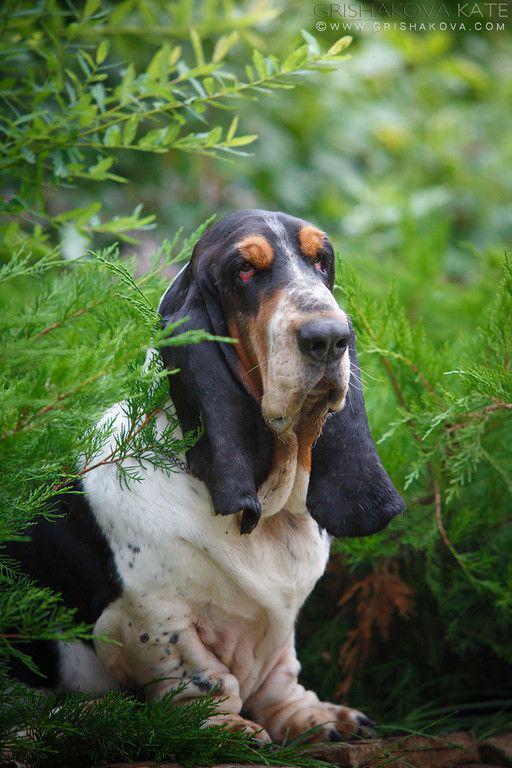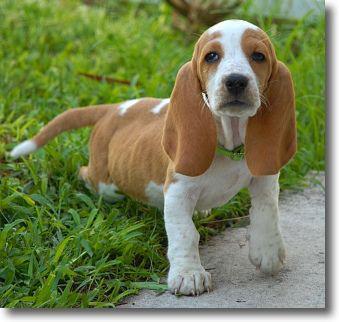The first image is the image on the left, the second image is the image on the right. Analyze the images presented: Is the assertion "One dog is howling." valid? Answer yes or no. No. The first image is the image on the left, the second image is the image on the right. Examine the images to the left and right. Is the description "The left image shows a howling basset hound with its head raised straight up, and the right image includes a basset hound with its ears flying in the wind." accurate? Answer yes or no. No. 